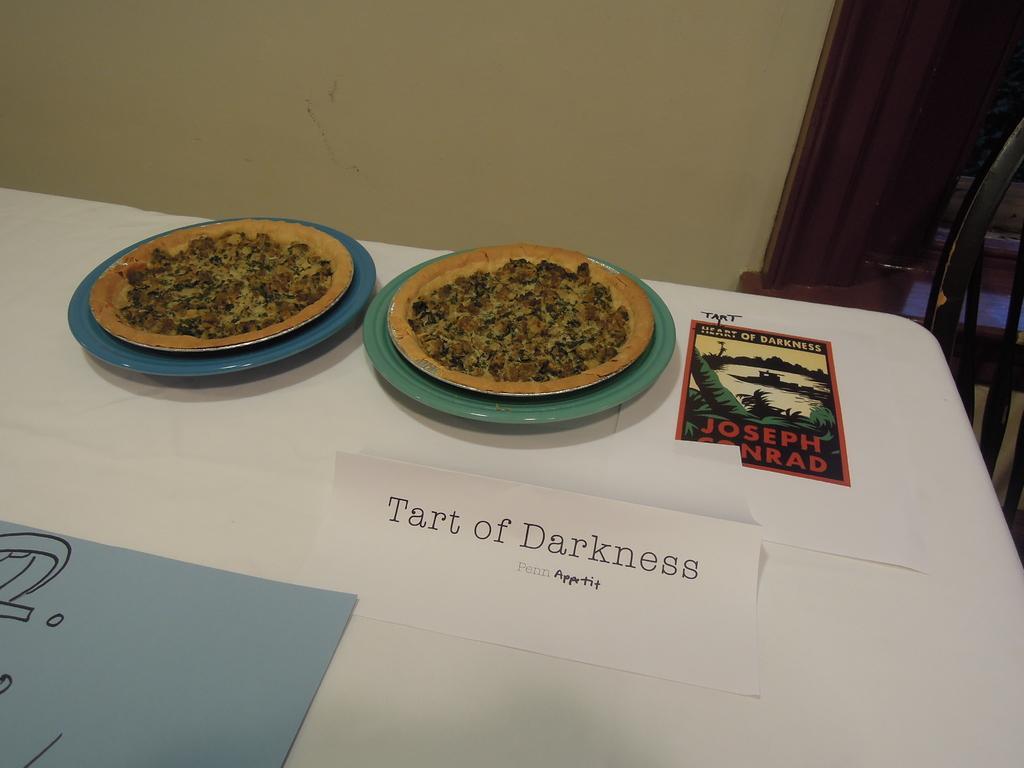Could you give a brief overview of what you see in this image? We can see planets with pizza, poster, paper and object on the table. In the background we can see wall, door and chair. 